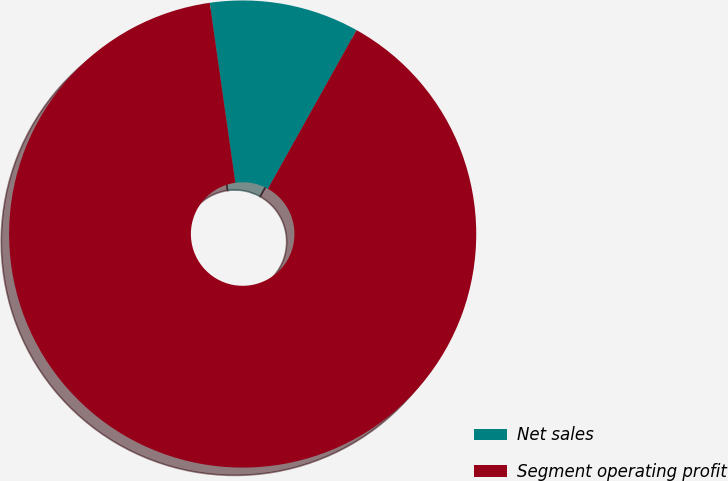<chart> <loc_0><loc_0><loc_500><loc_500><pie_chart><fcel>Net sales<fcel>Segment operating profit<nl><fcel>10.36%<fcel>89.64%<nl></chart> 